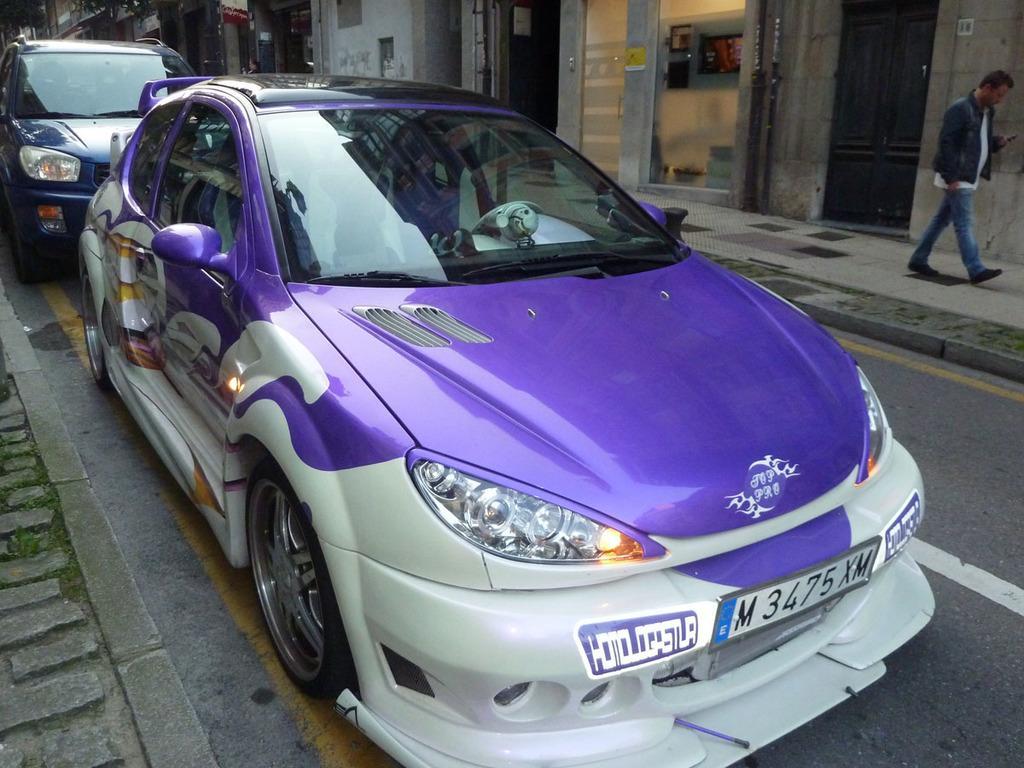Could you give a brief overview of what you see in this image? In this picture there is a car in the center of the image and there is another car behind it and there are doors and a person in the background area of the image, there are trees at the top side of the image. 